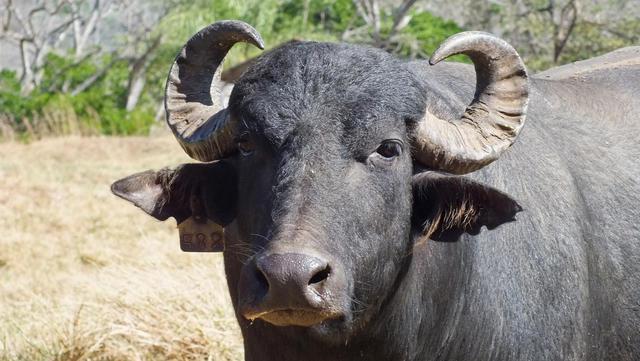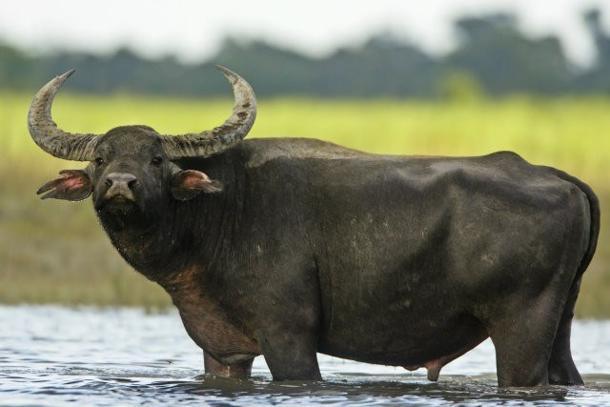The first image is the image on the left, the second image is the image on the right. Evaluate the accuracy of this statement regarding the images: "The left image features one camera-gazing water buffalo that is standing directly in front of a wet area.". Is it true? Answer yes or no. No. The first image is the image on the left, the second image is the image on the right. For the images shown, is this caption "There are exactly two African buffalo." true? Answer yes or no. Yes. 